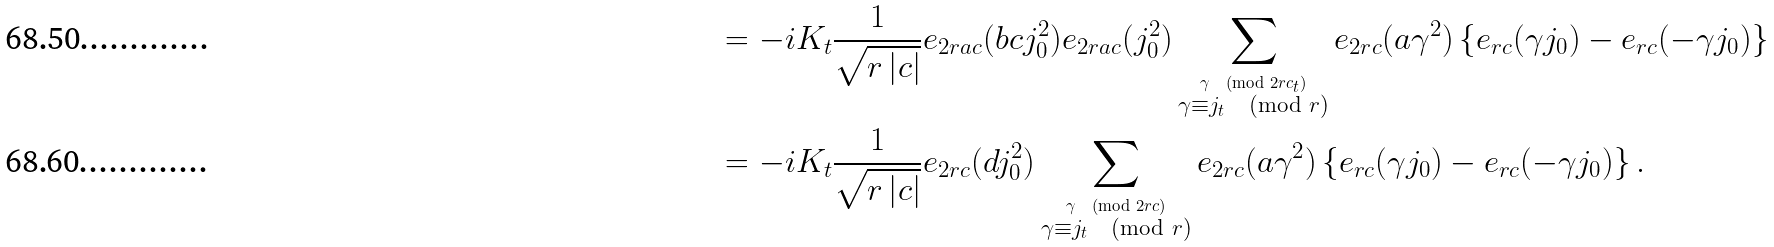Convert formula to latex. <formula><loc_0><loc_0><loc_500><loc_500>& = - i K _ { t } \frac { 1 } { \sqrt { r \left | c \right | } } e _ { 2 r a c } ( b c j _ { 0 } ^ { 2 } ) e _ { 2 r a c } ( j _ { 0 } ^ { 2 } ) \sum _ { \stackrel { \gamma \pmod { 2 r c _ { t } } } { \gamma \equiv j _ { t } \pmod { r } } } e _ { 2 r c } ( a \gamma ^ { 2 } ) \left \{ e _ { r c } ( \gamma j _ { 0 } ) - e _ { r c } ( - \gamma j _ { 0 } ) \right \} \\ & = - i K _ { t } \frac { 1 } { \sqrt { r \left | c \right | } } e _ { 2 r c } ( d j _ { 0 } ^ { 2 } ) \sum _ { \stackrel { \gamma \pmod { 2 r c } } { \gamma \equiv j _ { t } \pmod { r } } } e _ { 2 r c } ( a \gamma ^ { 2 } ) \left \{ e _ { r c } ( \gamma j _ { 0 } ) - e _ { r c } ( - \gamma j _ { 0 } ) \right \} .</formula> 